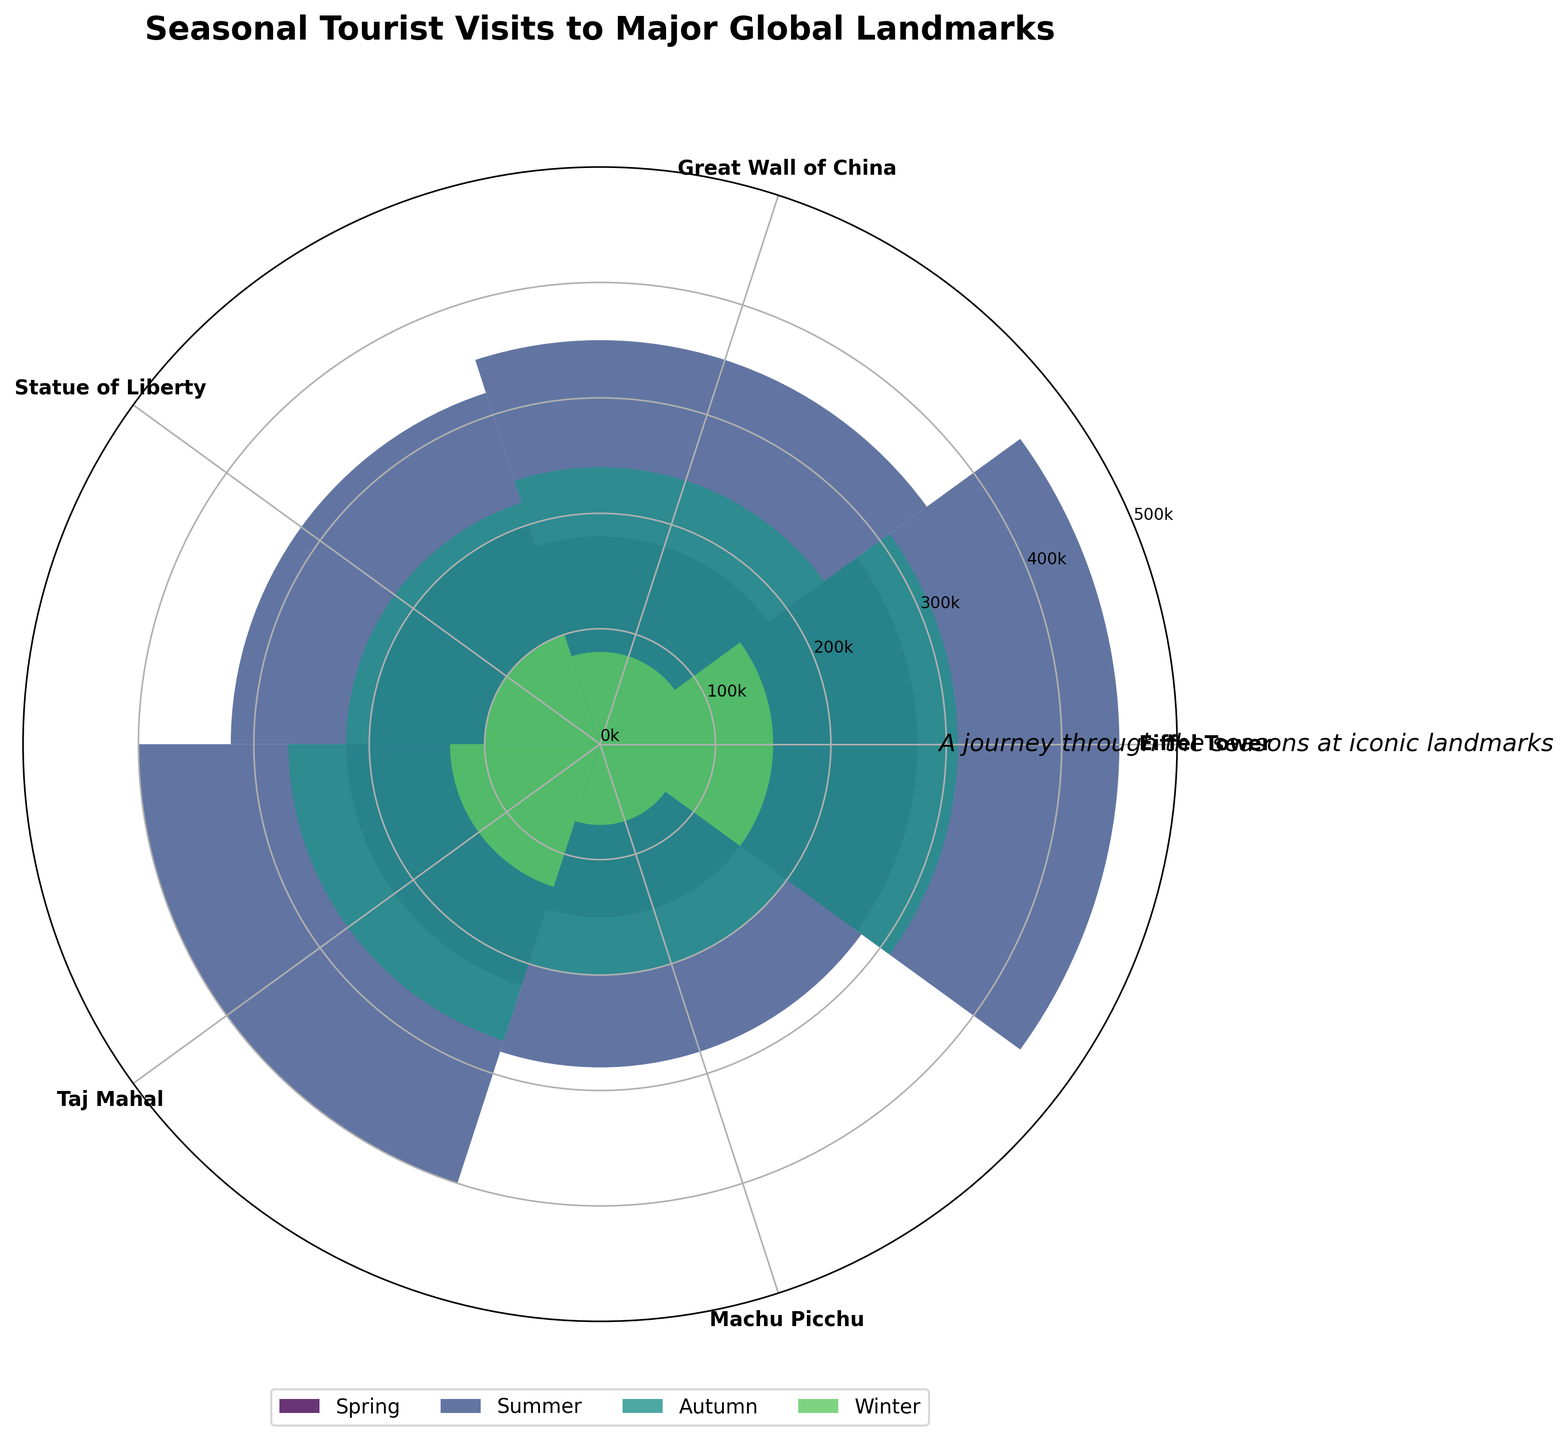What's the title of the figure? The title of the figure is prominently displayed at the top and reads "Seasonal Tourist Visits to Major Global Landmarks"
Answer: Seasonal Tourist Visits to Major Global Landmarks How many seasons are represented in the chart? The chart contains four different bars per landmark, each representing a different season: Spring, Summer, Autumn, and Winter.
Answer: 4 Which landmark has the highest number of visitors in Summer? By observing the height of the bars corresponding to Summer for each landmark, the Eiffel Tower has the tallest bar in the Summer season.
Answer: Eiffel Tower Is there any landmark that sees fewer than 100,000 visitors in Winter? The landmarks with bars representing Winter reaching below the 100,000 mark are the Great Wall of China and Machu Picchu.
Answer: Yes What's the seasonal trend for Machu Picchu based on the visitor data? For Machu Picchu, the visitor numbers increase from Winter to Summer: Winter (~70k), Spring (~150k), Autumn (~200k), and Summer (~280k).
Answer: Increasing from Winter to Summer, peaking in Summer Which season has the highest total visitor count across all landmarks? Summing up the visitor counts for all landmarks for each season, Summer has the highest total: Eiffel Tower (450k) + Great Wall of China (350k) + Statue of Liberty (320k) + Taj Mahal (400k) + Machu Picchu (280k) = 1800k.
Answer: Summer Which landmark has the smallest seasonal variation in visitors? The length of the bars for the Great Wall of China across all seasons seem relatively consistent compared to others, suggesting the smallest variation.
Answer: Great Wall of China Which landmark attracts the fewest visitors in Spring? The shortest bar representing the Spring season corresponds to Machu Picchu with 150k visitors.
Answer: Machu Picchu How do the summer visitor numbers for the Taj Mahal and the Statue of Liberty compare? The bar lengths show that the Taj Mahal has more visitors (400k) in Summer compared to the Statue of Liberty (320k).
Answer: The Taj Mahal has more visitors What is the range of visitors for the Eiffel Tower throughout the year? The range is calculated from the maximum to the minimum visitor counts: 450k (Summer) - 150k (Winter) = 300k.
Answer: 300k 